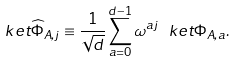Convert formula to latex. <formula><loc_0><loc_0><loc_500><loc_500>\ k e t { \widehat { \Phi } _ { A , j } } \equiv \frac { 1 } { \sqrt { d } } \sum _ { a = 0 } ^ { d - 1 } \omega ^ { a j } \ k e t { \Phi _ { A , a } } .</formula> 